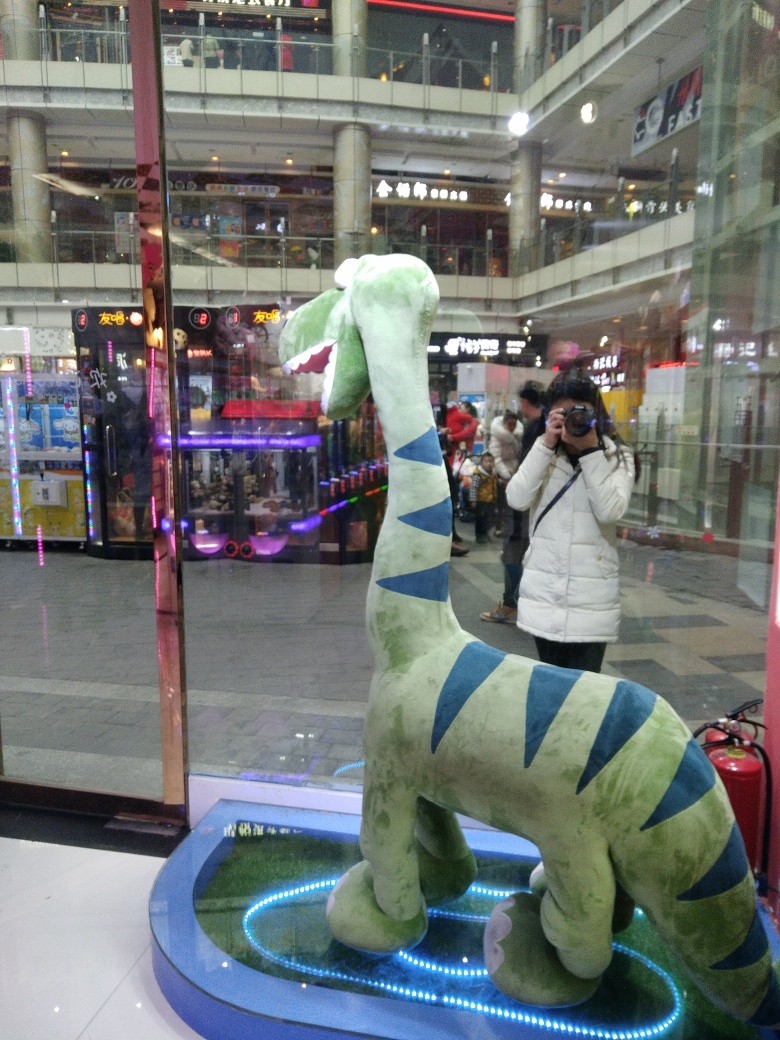Can you tell if the figure is meant for decoration or sale, and how does this affect its display? Given the context of a commercial setting, it's plausible that the figure is intended for sale. Its prominent display within the glass showcase suggests it's a feature item, possibly designed to attract attention and invite potential buyers to explore similar items within the store. What do you think is the target audience for this figure based on its design and placement? The figure's whimsical design and childish appeal indicate that the primary target audience is likely children. Its placement at eye level for young shoppers further suggests it's strategically positioned to capture the interest of younger demographics as they pass by. 